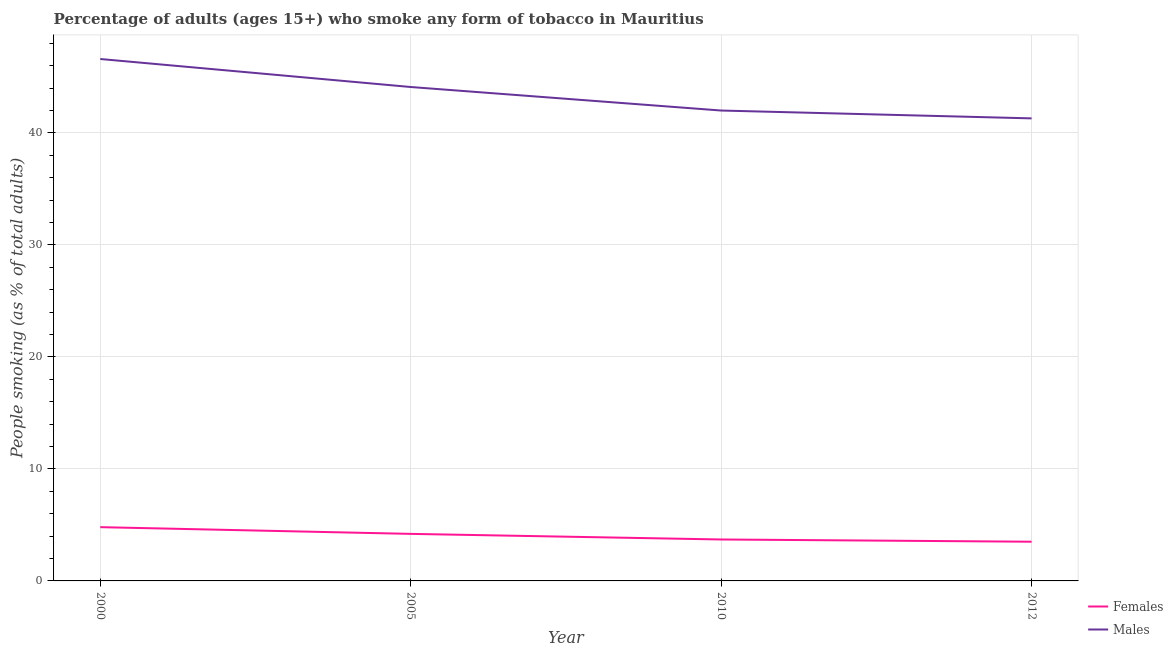How many different coloured lines are there?
Make the answer very short. 2. Is the number of lines equal to the number of legend labels?
Make the answer very short. Yes. What is the percentage of males who smoke in 2012?
Your answer should be very brief. 41.3. Across all years, what is the maximum percentage of males who smoke?
Keep it short and to the point. 46.6. Across all years, what is the minimum percentage of males who smoke?
Ensure brevity in your answer.  41.3. In which year was the percentage of males who smoke maximum?
Offer a terse response. 2000. In which year was the percentage of females who smoke minimum?
Ensure brevity in your answer.  2012. What is the difference between the percentage of females who smoke in 2005 and that in 2012?
Your response must be concise. 0.7. What is the difference between the percentage of males who smoke in 2005 and the percentage of females who smoke in 2012?
Your answer should be very brief. 40.6. What is the average percentage of males who smoke per year?
Provide a short and direct response. 43.5. In the year 2010, what is the difference between the percentage of females who smoke and percentage of males who smoke?
Your answer should be compact. -38.3. What is the ratio of the percentage of females who smoke in 2000 to that in 2010?
Make the answer very short. 1.3. Is the percentage of females who smoke in 2000 less than that in 2010?
Keep it short and to the point. No. What is the difference between the highest and the second highest percentage of males who smoke?
Ensure brevity in your answer.  2.5. What is the difference between the highest and the lowest percentage of females who smoke?
Give a very brief answer. 1.3. In how many years, is the percentage of females who smoke greater than the average percentage of females who smoke taken over all years?
Provide a succinct answer. 2. Is the sum of the percentage of females who smoke in 2005 and 2012 greater than the maximum percentage of males who smoke across all years?
Offer a terse response. No. Does the percentage of females who smoke monotonically increase over the years?
Ensure brevity in your answer.  No. Is the percentage of females who smoke strictly greater than the percentage of males who smoke over the years?
Give a very brief answer. No. Is the percentage of males who smoke strictly less than the percentage of females who smoke over the years?
Give a very brief answer. No. Are the values on the major ticks of Y-axis written in scientific E-notation?
Ensure brevity in your answer.  No. What is the title of the graph?
Your answer should be very brief. Percentage of adults (ages 15+) who smoke any form of tobacco in Mauritius. Does "Total Population" appear as one of the legend labels in the graph?
Provide a short and direct response. No. What is the label or title of the Y-axis?
Provide a succinct answer. People smoking (as % of total adults). What is the People smoking (as % of total adults) of Males in 2000?
Ensure brevity in your answer.  46.6. What is the People smoking (as % of total adults) of Females in 2005?
Your response must be concise. 4.2. What is the People smoking (as % of total adults) in Males in 2005?
Provide a short and direct response. 44.1. What is the People smoking (as % of total adults) in Females in 2012?
Provide a short and direct response. 3.5. What is the People smoking (as % of total adults) in Males in 2012?
Provide a succinct answer. 41.3. Across all years, what is the maximum People smoking (as % of total adults) in Males?
Your answer should be compact. 46.6. Across all years, what is the minimum People smoking (as % of total adults) in Females?
Provide a short and direct response. 3.5. Across all years, what is the minimum People smoking (as % of total adults) in Males?
Offer a terse response. 41.3. What is the total People smoking (as % of total adults) in Females in the graph?
Provide a succinct answer. 16.2. What is the total People smoking (as % of total adults) in Males in the graph?
Offer a very short reply. 174. What is the difference between the People smoking (as % of total adults) of Females in 2000 and that in 2005?
Make the answer very short. 0.6. What is the difference between the People smoking (as % of total adults) in Males in 2000 and that in 2010?
Offer a very short reply. 4.6. What is the difference between the People smoking (as % of total adults) of Females in 2005 and that in 2010?
Your response must be concise. 0.5. What is the difference between the People smoking (as % of total adults) of Females in 2005 and that in 2012?
Give a very brief answer. 0.7. What is the difference between the People smoking (as % of total adults) of Males in 2010 and that in 2012?
Your answer should be compact. 0.7. What is the difference between the People smoking (as % of total adults) of Females in 2000 and the People smoking (as % of total adults) of Males in 2005?
Give a very brief answer. -39.3. What is the difference between the People smoking (as % of total adults) of Females in 2000 and the People smoking (as % of total adults) of Males in 2010?
Your response must be concise. -37.2. What is the difference between the People smoking (as % of total adults) of Females in 2000 and the People smoking (as % of total adults) of Males in 2012?
Your answer should be compact. -36.5. What is the difference between the People smoking (as % of total adults) in Females in 2005 and the People smoking (as % of total adults) in Males in 2010?
Give a very brief answer. -37.8. What is the difference between the People smoking (as % of total adults) of Females in 2005 and the People smoking (as % of total adults) of Males in 2012?
Your response must be concise. -37.1. What is the difference between the People smoking (as % of total adults) of Females in 2010 and the People smoking (as % of total adults) of Males in 2012?
Keep it short and to the point. -37.6. What is the average People smoking (as % of total adults) in Females per year?
Offer a very short reply. 4.05. What is the average People smoking (as % of total adults) of Males per year?
Ensure brevity in your answer.  43.5. In the year 2000, what is the difference between the People smoking (as % of total adults) in Females and People smoking (as % of total adults) in Males?
Provide a short and direct response. -41.8. In the year 2005, what is the difference between the People smoking (as % of total adults) of Females and People smoking (as % of total adults) of Males?
Offer a very short reply. -39.9. In the year 2010, what is the difference between the People smoking (as % of total adults) of Females and People smoking (as % of total adults) of Males?
Make the answer very short. -38.3. In the year 2012, what is the difference between the People smoking (as % of total adults) in Females and People smoking (as % of total adults) in Males?
Offer a terse response. -37.8. What is the ratio of the People smoking (as % of total adults) of Males in 2000 to that in 2005?
Provide a succinct answer. 1.06. What is the ratio of the People smoking (as % of total adults) of Females in 2000 to that in 2010?
Offer a terse response. 1.3. What is the ratio of the People smoking (as % of total adults) of Males in 2000 to that in 2010?
Your answer should be very brief. 1.11. What is the ratio of the People smoking (as % of total adults) of Females in 2000 to that in 2012?
Provide a succinct answer. 1.37. What is the ratio of the People smoking (as % of total adults) in Males in 2000 to that in 2012?
Give a very brief answer. 1.13. What is the ratio of the People smoking (as % of total adults) in Females in 2005 to that in 2010?
Give a very brief answer. 1.14. What is the ratio of the People smoking (as % of total adults) in Females in 2005 to that in 2012?
Offer a terse response. 1.2. What is the ratio of the People smoking (as % of total adults) in Males in 2005 to that in 2012?
Keep it short and to the point. 1.07. What is the ratio of the People smoking (as % of total adults) of Females in 2010 to that in 2012?
Your answer should be very brief. 1.06. What is the ratio of the People smoking (as % of total adults) in Males in 2010 to that in 2012?
Your response must be concise. 1.02. What is the difference between the highest and the lowest People smoking (as % of total adults) in Males?
Make the answer very short. 5.3. 